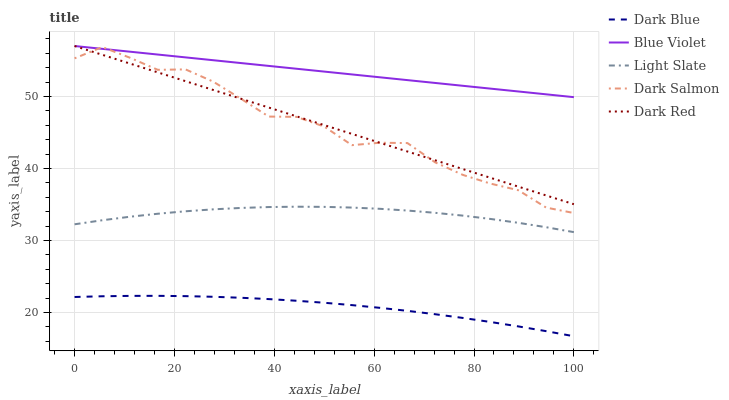Does Dark Blue have the minimum area under the curve?
Answer yes or no. Yes. Does Blue Violet have the maximum area under the curve?
Answer yes or no. Yes. Does Dark Salmon have the minimum area under the curve?
Answer yes or no. No. Does Dark Salmon have the maximum area under the curve?
Answer yes or no. No. Is Blue Violet the smoothest?
Answer yes or no. Yes. Is Dark Salmon the roughest?
Answer yes or no. Yes. Is Dark Blue the smoothest?
Answer yes or no. No. Is Dark Blue the roughest?
Answer yes or no. No. Does Dark Blue have the lowest value?
Answer yes or no. Yes. Does Dark Salmon have the lowest value?
Answer yes or no. No. Does Dark Red have the highest value?
Answer yes or no. Yes. Does Dark Salmon have the highest value?
Answer yes or no. No. Is Dark Blue less than Dark Red?
Answer yes or no. Yes. Is Dark Salmon greater than Light Slate?
Answer yes or no. Yes. Does Blue Violet intersect Dark Salmon?
Answer yes or no. Yes. Is Blue Violet less than Dark Salmon?
Answer yes or no. No. Is Blue Violet greater than Dark Salmon?
Answer yes or no. No. Does Dark Blue intersect Dark Red?
Answer yes or no. No. 